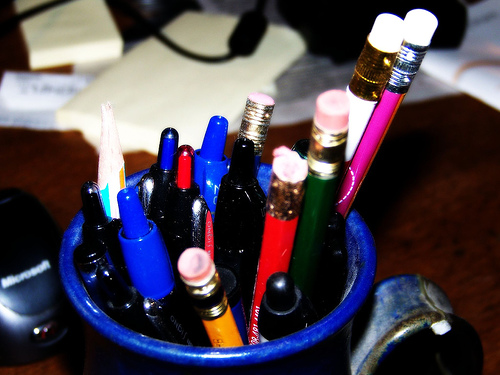<image>
Is the pen to the right of the pen holder? No. The pen is not to the right of the pen holder. The horizontal positioning shows a different relationship. 